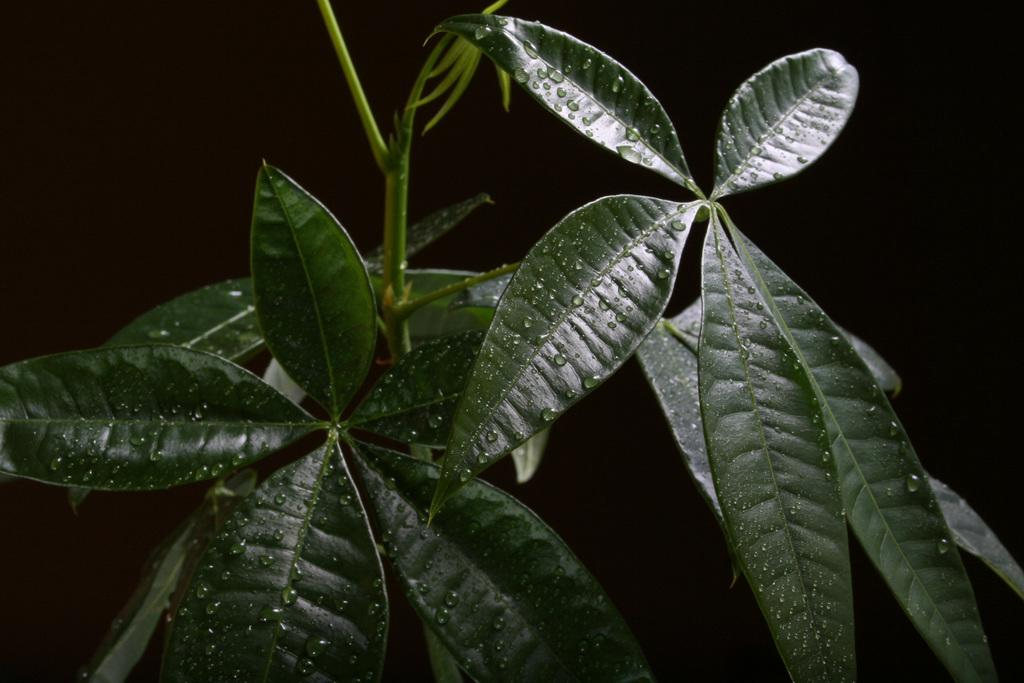What can be observed about the composition of the image? The image appears to be zoomed in. Where might the image have been taken? The image was likely clicked outside, given the presence of a plant in the foreground. What is visible in the foreground of the image? There are green leaves and stems of a plant in the foreground. How would you describe the lighting in the background of the image? The background of the image is very dark. How does the person in the image express regret about their failed attempt to head the soccer ball? There is no person present in the image, and therefore no expression of regret or failed attempt to head a soccer ball can be observed. 